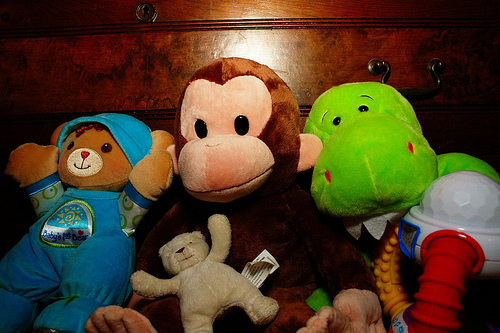<image>
Can you confirm if the bear is on the monkey? Yes. Looking at the image, I can see the bear is positioned on top of the monkey, with the monkey providing support. Is the monkey on the bear? No. The monkey is not positioned on the bear. They may be near each other, but the monkey is not supported by or resting on top of the bear. Where is the teddy bear in relation to the monkey? Is it in front of the monkey? Yes. The teddy bear is positioned in front of the monkey, appearing closer to the camera viewpoint. 